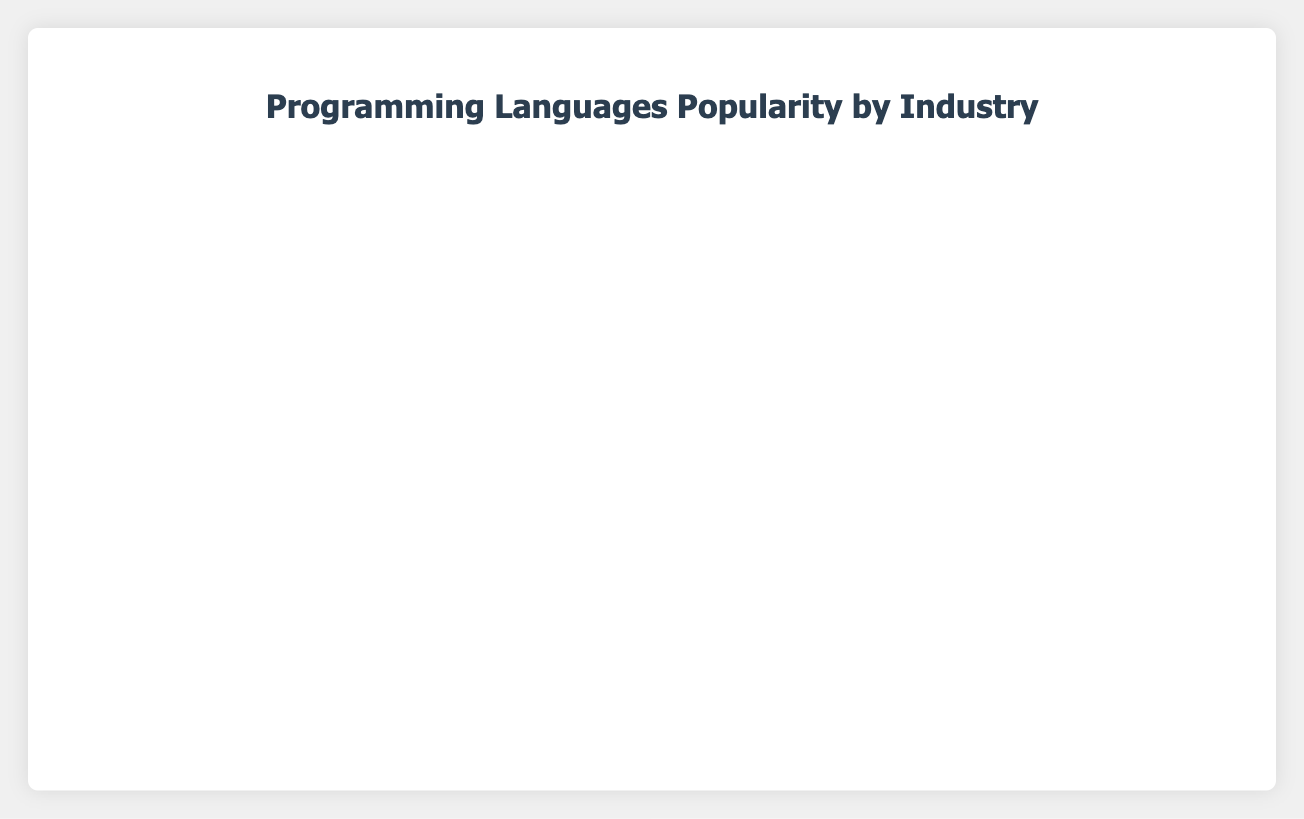Which industry has the highest percentage of Python usage? Look at the bar that represents Python within each industry. The longest bar for Python is in the Education industry.
Answer: Education What is the total percentage of JavaScript usage in the Finance and Healthcare sectors combined? Add the percentage values for JavaScript in Finance (10%) and Healthcare (10%). So, the total is 10% + 10% = 20%.
Answer: 20% How does Java's popularity in Manufacturing compare to its popularity in Retail? Compare the length of the bars representing Java in Manufacturing (25%) and Retail (20%). Java has a higher percentage in Manufacturing.
Answer: Manufacturing What two industries have an equal percentage of JavaScript usage? Look at the bars representing JavaScript across all industries and find which two have the same length. Finance and Healthcare both have 10% JavaScript usage.
Answer: Finance, Healthcare Which programming language has the highest combined percentage usage across all industries, specifically in the Government sector? Look at the Government sector and sum up the percentages for all languages. Java has 30%, Python has 25%, C# has 20%, JavaScript has 15%, R has 10%. Java, with 30%, is the highest.
Answer: Java What is the ratio of Python's usage between the Finance and Technology sectors? Note the percentages for Python in Finance (40%) and Technology (30%). The ratio is 40:30, which simplifies to 4:3.
Answer: 4:3 Among the listed industries, which one shows the lowest overall usage of programming languages other than JavaScript? Calculate the total percentages for all programming languages other than JavaScript. Find the industry with the smallest sum. In Telecommunications, the other languages sum up to 35% + 25% + 20% + 5% = 85%, which is the lowest.
Answer: Telecommunications What is the average percentage usage of C# across all industries? Note C# usage in each sector: Finance (20%), Healthcare (10%), Manufacturing (30%), Telecommunications (5%), Government (20%). Sum these up (20 + 10 + 30 + 5 + 20 = 85) and divide by the number of industries with C# (5). The average is 85/5 = 17%.
Answer: 17% How does the popularity of Python in Education compare with that in Retail? Observe the lengths of the Python bars in Education (50%) and Retail (25%). Python is twice as popular in Education compared to Retail.
Answer: Education has twice the popularity What industry exclusively uses Ruby within the given data? Look across all industries and find the bars for Ruby. Ruby is only present in Technology (5%) and Retail (10%). Since it's not exclusive, there's no such industry.
Answer: None 